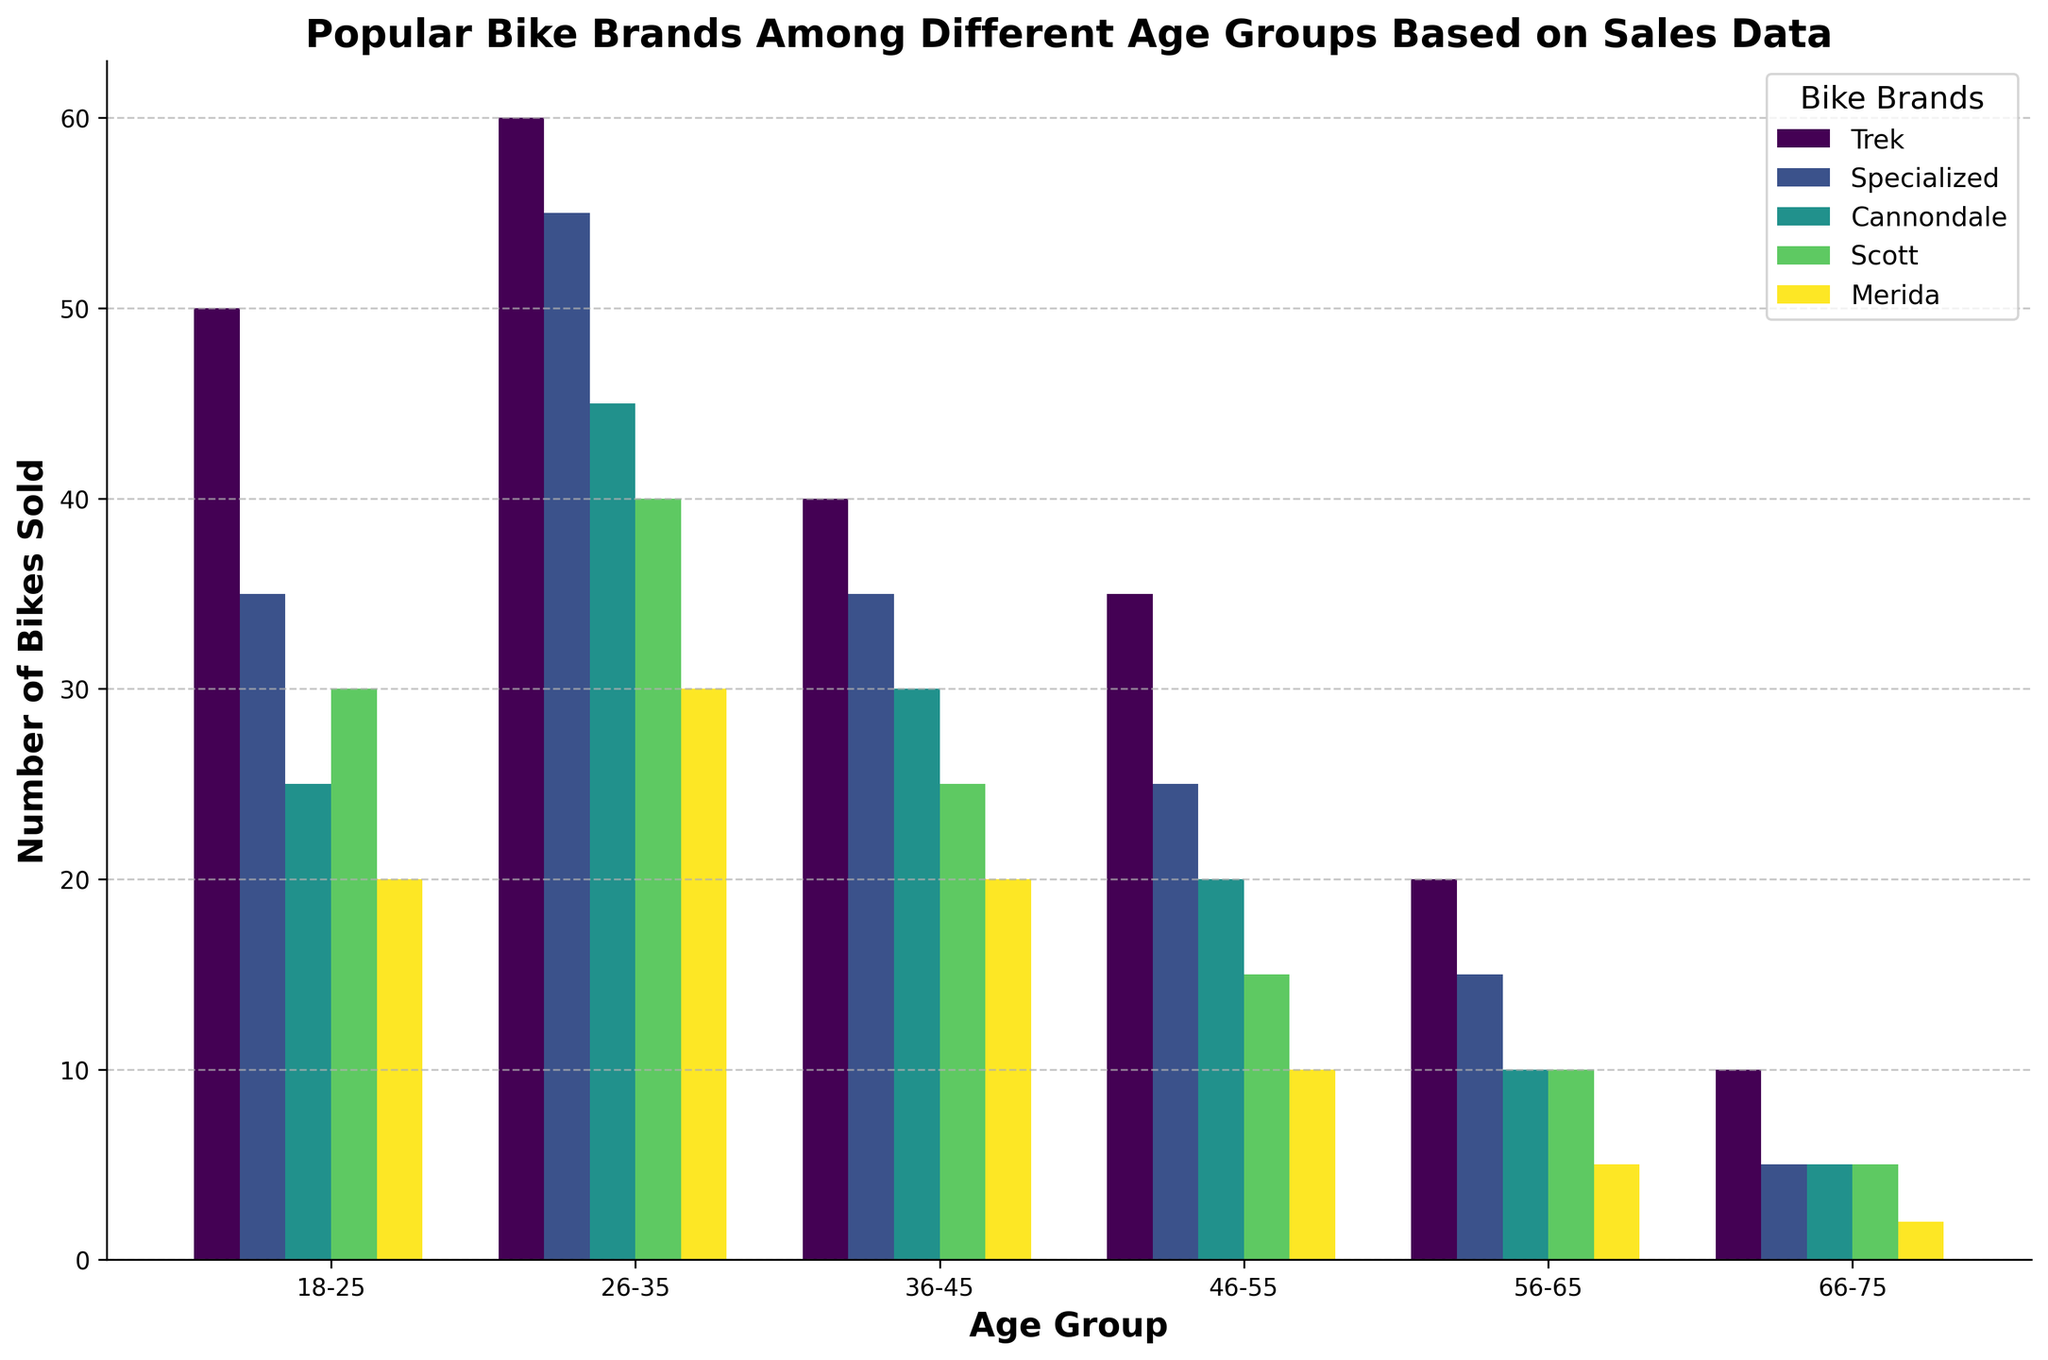Which bike brand is the most popular among the 26-35 age group? By looking at the height of the bars for each bike brand within the 26-35 age group, it is evident that the Trek bar is the tallest, indicating the highest number of sales.
Answer: Trek Which age group has the highest sales for the Cannondale bike brand? By comparing the height of the Cannondale bars across all age groups, the highest bar is seen in the 26-35 age group.
Answer: 26-35 Which bike brand experienced a decrease in popularity in the older age groups starting from 46-55? Observing the Merida bars, we see a gradual decrease in bar height from the 46-55 age group onwards, indicating fewer sales.
Answer: Merida What is the difference in sales of Trek bikes between the 18-25 age group and the 36-45 age group? The sales for the Trek brand in the 18-25 age group are 50, while the sales in the 36-45 age group are 40. The difference is 50 - 40.
Answer: 10 Which two bike brands have the closest sales figures in the 56-65 age group? Observing the bars in the 56-65 age group, Scott and Cannondale have the closest sales figures with bars of nearly equal height.
Answer: Scott and Cannondale In which age group does the Specialized brand outperform the Trek brand? Comparing the height of the Specialized and Trek bars across all age groups, there is no age group where the Specialized bar is taller than the Trek bar.
Answer: None What is the total number of bikes sold for the Scott brand? Summing up the sales data for the Scott brand across all age groups (30 + 40 + 25 + 15 + 10 + 5) gives the total sales.
Answer: 125 Which age group purchases the least number of bikes overall, and which bike brand contributes the least to this age group? The 66-75 age group has the shortest bars overall, and Merida has the smallest individual bar in this age group.
Answer: 66-75, Merida How many more Trek bikes are sold compared to Merida bikes in the 26-35 age group? The sales for Trek in the 26-35 age group are 60, and the sales for Merida are 30. The difference is 60 - 30.
Answer: 30 What trend do you observe in the sales of Specialized bikes as the age group increases from 18-25 to 66-75? Observing the height of the Specialized bars, there is a clear downward trend in sales as the age group increases from 18-25 to 66-75.
Answer: Downward trend 